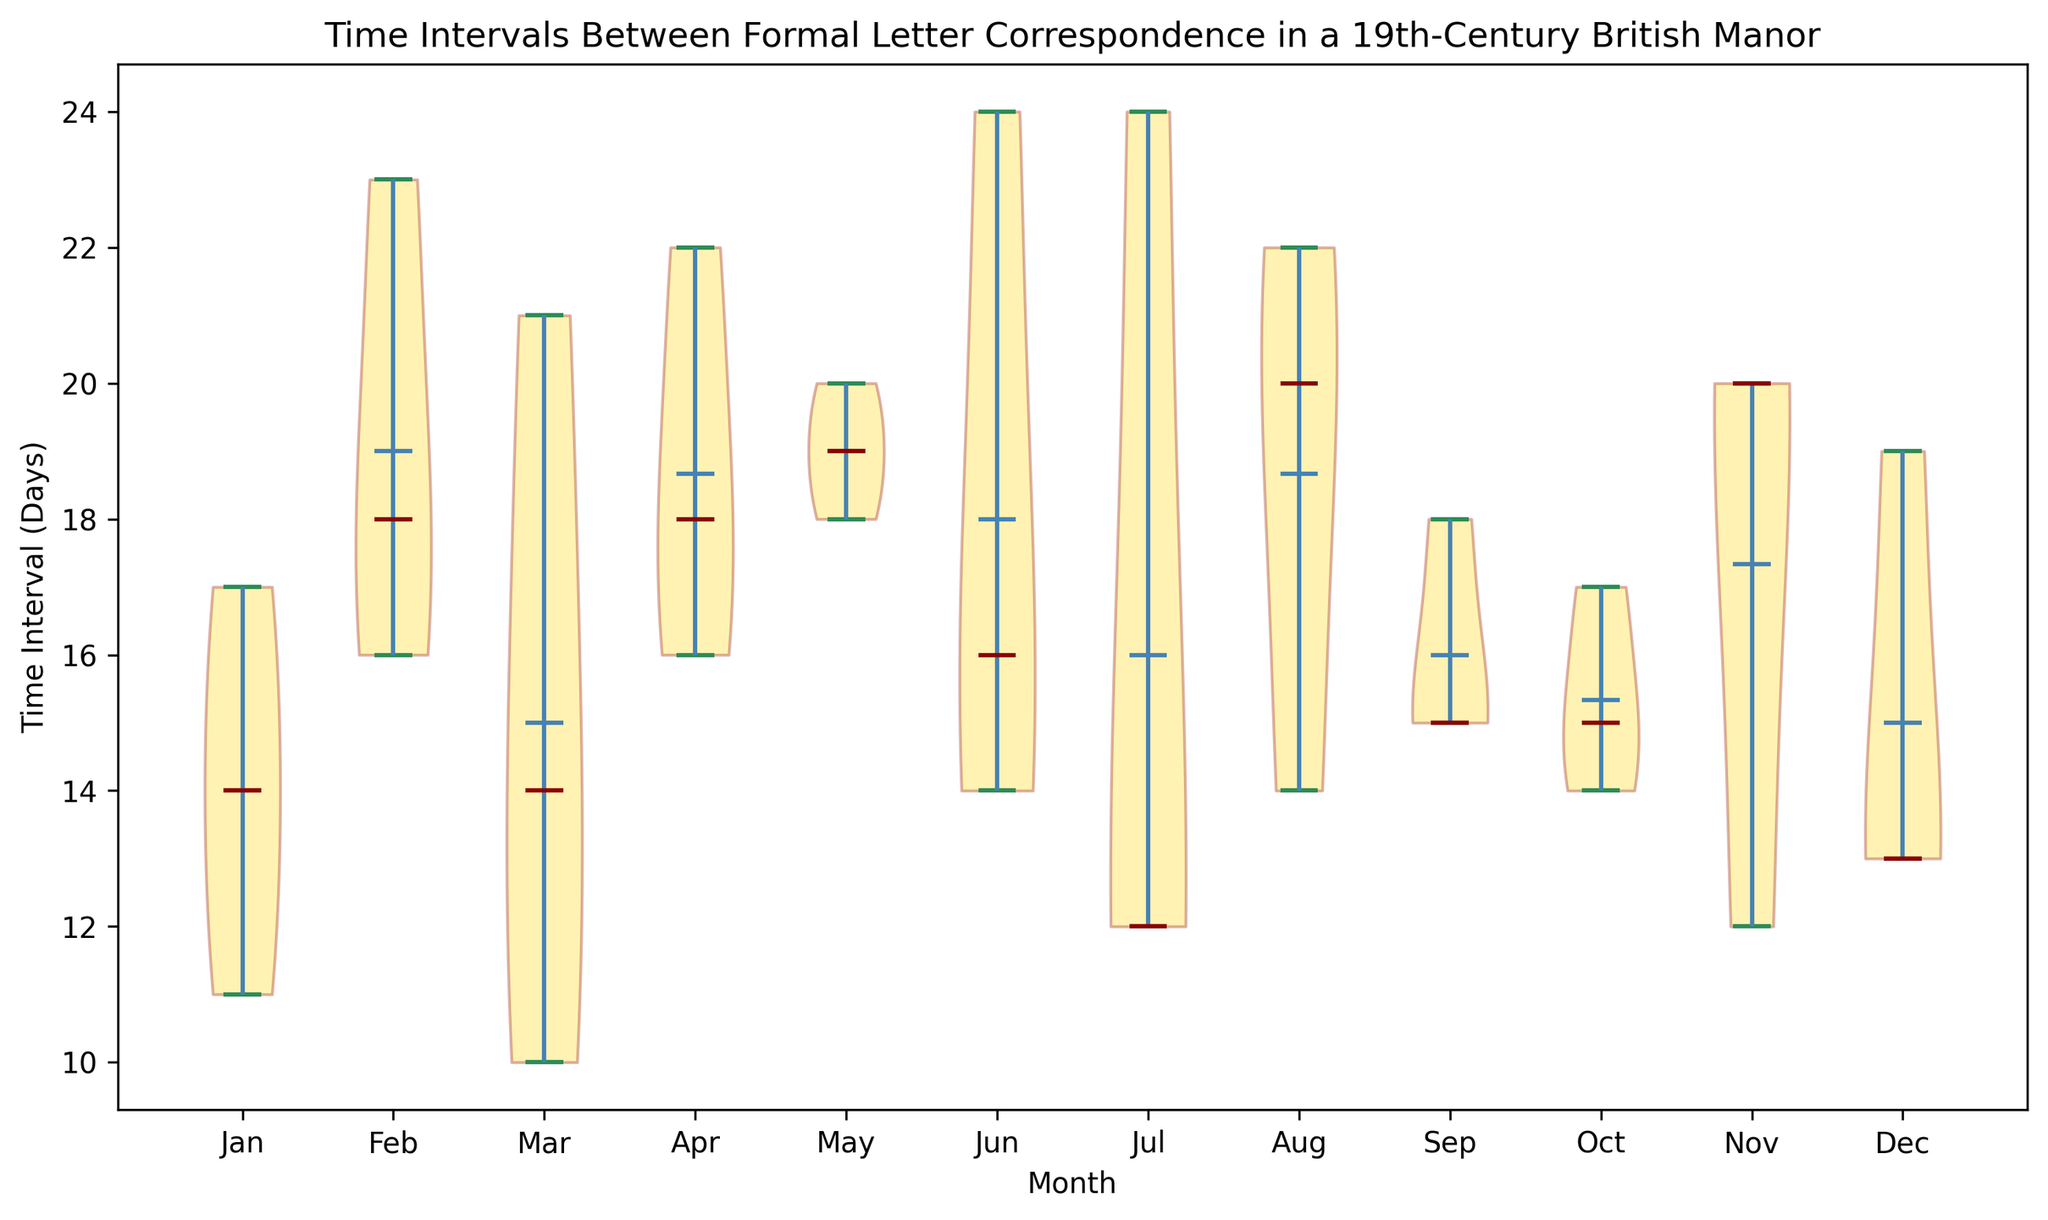Which month has the shortest median time interval between correspondences? By observing the position of the median markers (horizontal lines inside each violin), we can identify which month has the shortest one. The marker closest to the bottom of the y-axis indicates the shortest median interval.
Answer: January Which month shows the widest range of time intervals in the plot? By analyzing the overall spread of the violins, including the narrowest and widest points, we can see which month has the largest range between the minimum and maximum time intervals. This is visually apparent in the month with the tallest and widest violin shape.
Answer: July Which two months have nearly equal means of time intervals between correspondences? By looking at the position of the mean markers (dots) inside each violin, we can compare the months to find two that have similarly positioned markers along the y-axis. These would correspond to nearly equal mean intervals.
Answer: May and August Are there any months where the mean time interval is less than the median time interval? To determine this, observe the position of the mean markers (dots) relative to the median markers (horizontal lines) inside each violin. If the mean marker is below the median marker, the mean interval is less.
Answer: Yes, April Which month shows the most symmetrical distribution of time intervals? A symmetrical distribution in a violin plot will have similar shapes and widths on both sides of the axis, indicating equal spread above and below the median.
Answer: October Which month has the highest variability in the time intervals of correspondences? Variability can be assessed by the width and spread of the violin. The month with the broadest and most varied shape indicates higher variability within that dataset.
Answer: July What is the median time interval for the month of November? The median can be identified by the horizontal line within the November violin plot. We need to note its y-axis value to determine the median interval.
Answer: 20 Which month has the median time interval closest to 14 days? We need to identify the month with the median marker (horizontal line) closest to the 14 days mark on the y-axis to find this information.
Answer: June Are there any months where the mean time interval is visually higher than 20 days? Looking at the mean markers (dots) within each violin plot, we can identify if any of these are positioned above the 20 days line on the y-axis.
Answer: Yes, February Which months have the least variability and smallest spread in time intervals? Least variability is indicated by the narrowest and shortest violin plots. These would be the plots with the least amount of vertical spread between minimum and maximum values.
Answer: March and June 